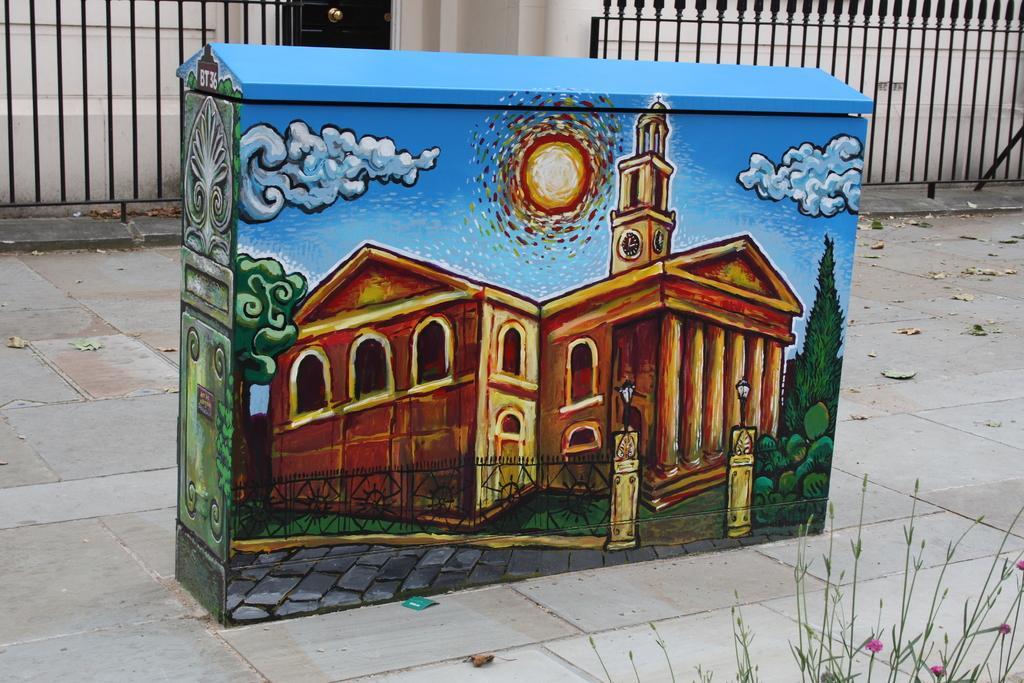Describe this image in one or two sentences. This image is taken outdoors. At the bottom of the image there is grass and there is a floor. In the background there is a wall and there are two railings. In the middle of the image there is an object with a few paintings on it. 